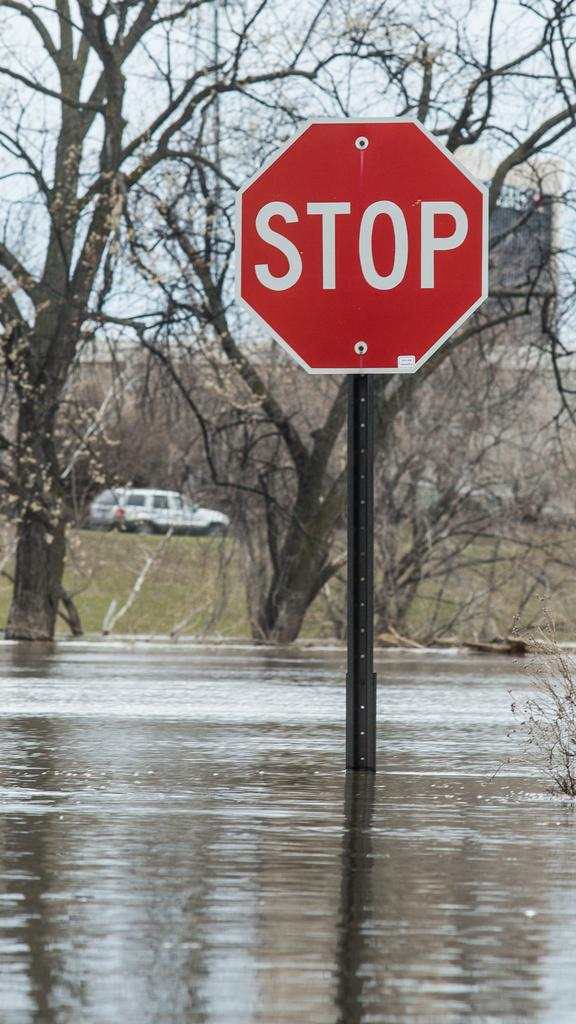<image>
Create a compact narrative representing the image presented. The pole of a stop sign is submerged in water and a car can be seen in the background. 